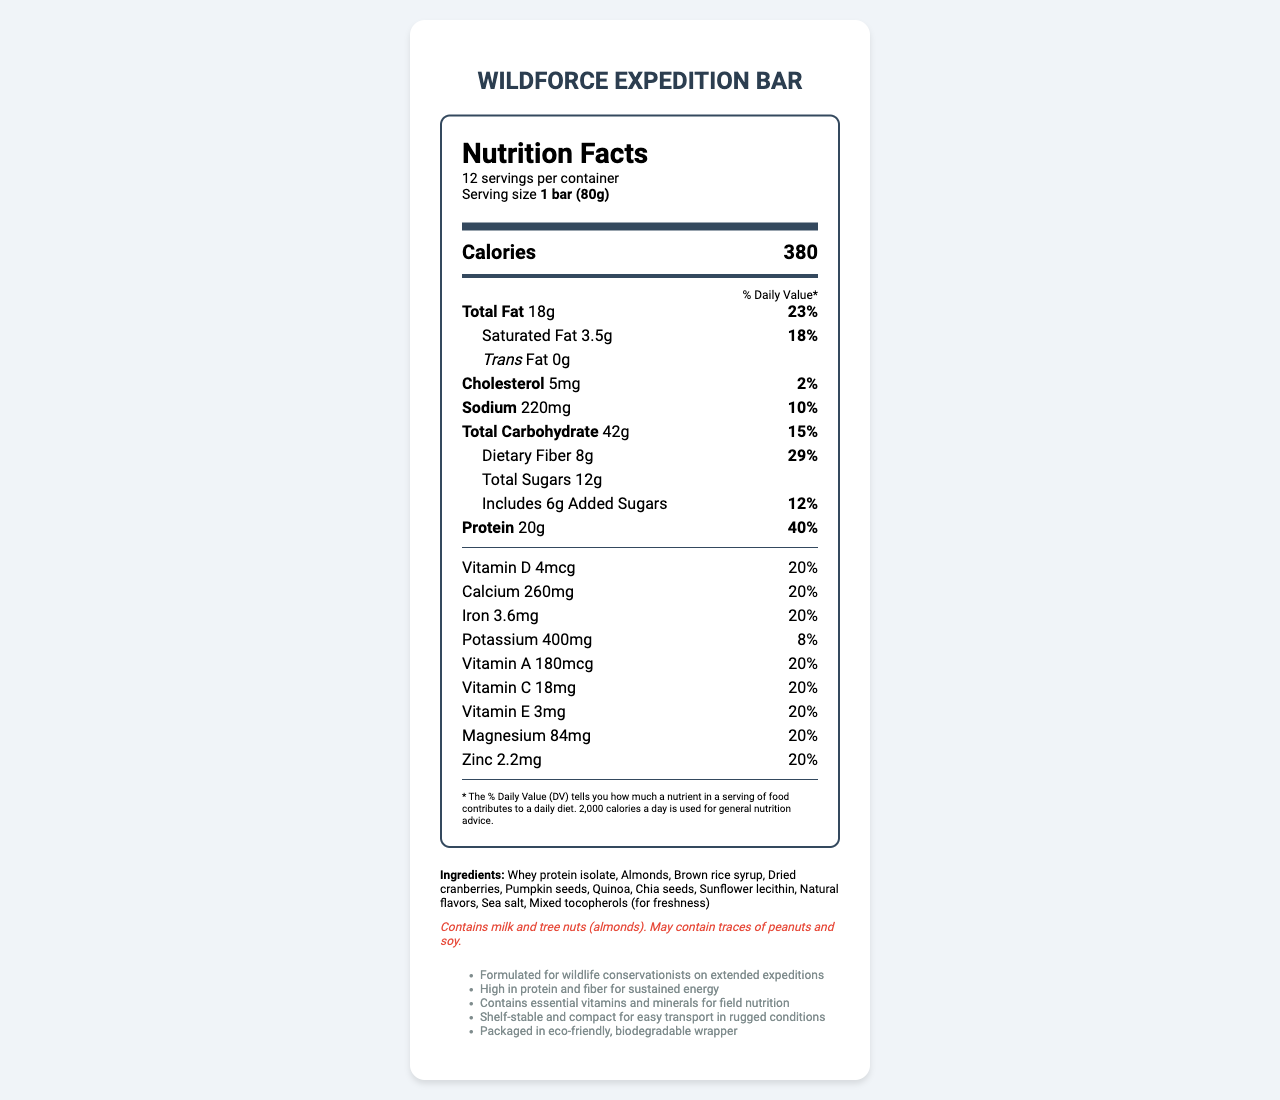what is the serving size of the WildForce Expedition Bar? The serving size is specified in the "serving info" section as "1 bar (80g)".
Answer: 1 bar (80g) How many calories are in one serving of the WildForce Expedition Bar? The calories per serving are listed as 380 in the document.
Answer: 380 What are the two main sources of fat in this bar? The ingredients list includes "Almonds" and "Pumpkin seeds," both of which are high in fat.
Answer: Almonds, Pumpkin seeds What percentage of the daily value of protein does the bar provide? The document states that the bar provides 20g of protein, which is 40% of the daily value.
Answer: 40% How much dietary fiber does one bar contain? The dietary fiber content per serving is listed as 8g in the document.
Answer: 8g How many servings does each container of WildForce Expedition Bars have? Each container has 12 servings, as indicated in the "serving info" section.
Answer: 12 What is the amount of sodium per serving? The nutrition label lists sodium content as 220mg per serving.
Answer: 220mg According to the label, which vitamin is NOT listed as being present in the bar? A. Vitamin B12 B. Vitamin C C. Vitamin D D. Vitamin A The document lists Vitamin C, Vitamin D, and Vitamin A, but does not mention Vitamin B12.
Answer: A. Vitamin B12 How much calcium is in each serving of the WildForce Expedition Bar? A. 200mg B. 220mg C. 240mg D. 260mg The nutrition label states that there are 260mg of calcium per serving.
Answer: D. 260mg Does the bar contain any trans fat? The trans fat amount is listed as 0g in the nutrition label.
Answer: No Is the WildForce Expedition Bar designed for short trips? (Yes/No) The additional information specifies that the bar is formulated for extended expeditions, not short trips.
Answer: No Summarize the main purpose and features of the WildForce Expedition Bar. The main purpose of the WildForce Expedition Bar is to support the nutritional needs of wildlife conservationists during extended fieldwork. It includes features such as high protein and fiber content, essential vitamins and minerals, and eco-friendly packaging.
Answer: The WildForce Expedition Bar is a nutrient-dense meal replacement bar designed for wildlife conservationists on extended expeditions. It is high in protein and fiber, contains essential vitamins and minerals, and is packaged in an eco-friendly, biodegradable wrapper. It is designed to provide sustained energy and nutrition in rugged conditions. What is the main protein source in the WildForce Expedition Bar? The ingredients list states that whey protein isolate is one of the main components, and it is a significant source of protein.
Answer: Whey protein isolate Can we determine the cost of one container of WildForce Expedition Bars from the document? The document does not provide any information regarding the cost of the product.
Answer: Cannot be determined How much added sugar does each bar have? The document specifies that each bar contains 6g of added sugars.
Answer: 6g What allergens should potential consumers be aware of before eating the bar? The allergen information section states that the bar contains milk and tree nuts (almonds) and may contain traces of peanuts and soy.
Answer: Milk and tree nuts (almonds). May contain traces of peanuts and soy. What vitamin content in the bar matches a daily value of 20% for each serving? According to the document, the daily value for Vitamin D, Vitamin A, Vitamin C, Vitamin E, Calcium, Iron, Magnesium, and Zinc is 20%.
Answer: Vitamin D, Vitamin A, Vitamin C, Vitamin E, Calcium, Iron, Magnesium, Zinc 